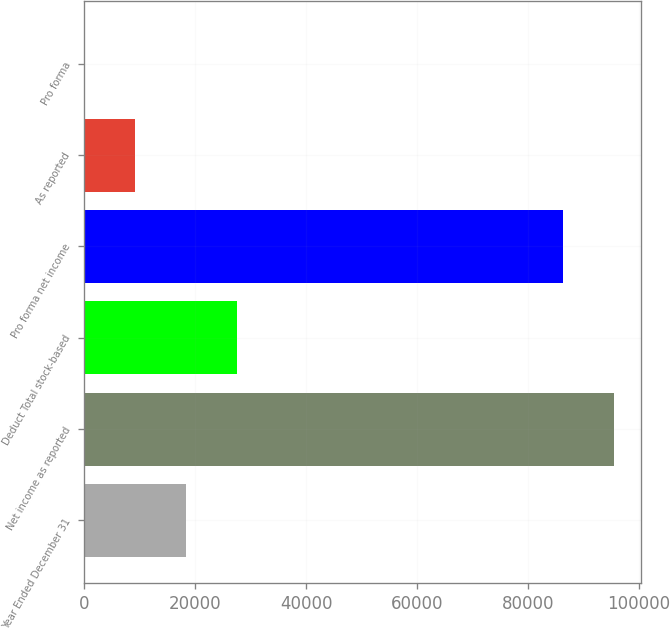Convert chart to OTSL. <chart><loc_0><loc_0><loc_500><loc_500><bar_chart><fcel>Year Ended December 31<fcel>Net income as reported<fcel>Deduct Total stock-based<fcel>Pro forma net income<fcel>As reported<fcel>Pro forma<nl><fcel>18340.7<fcel>95491.4<fcel>27510.1<fcel>86322<fcel>9171.25<fcel>1.83<nl></chart> 